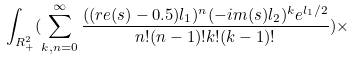Convert formula to latex. <formula><loc_0><loc_0><loc_500><loc_500>\int _ { \L R _ { + } ^ { 2 } } ( \sum _ { k , n = 0 } ^ { \infty } \frac { ( ( r e ( s ) - 0 . 5 ) l _ { 1 } ) ^ { n } ( - i m ( s ) l _ { 2 } ) ^ { k } e ^ { l _ { 1 } / 2 } } { n ! ( n - 1 ) ! k ! ( k - 1 ) ! } ) \times</formula> 